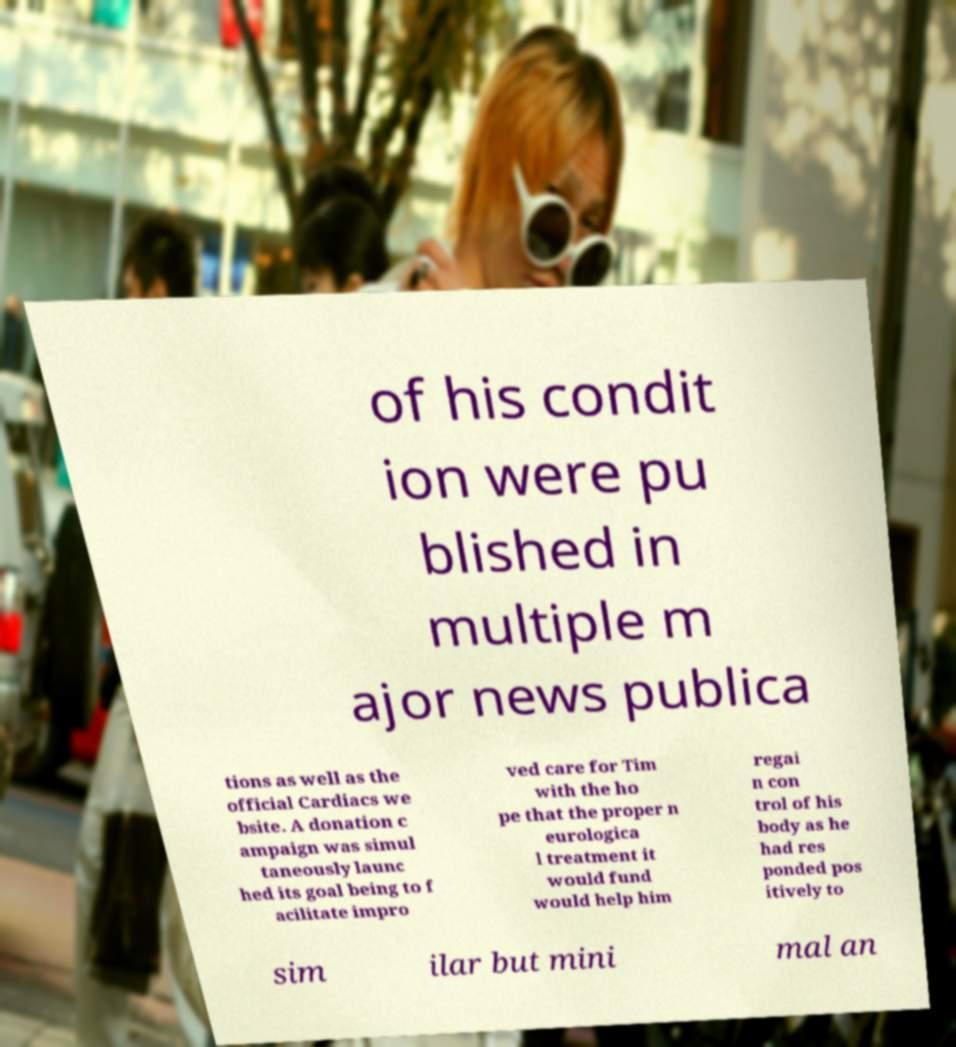Could you extract and type out the text from this image? of his condit ion were pu blished in multiple m ajor news publica tions as well as the official Cardiacs we bsite. A donation c ampaign was simul taneously launc hed its goal being to f acilitate impro ved care for Tim with the ho pe that the proper n eurologica l treatment it would fund would help him regai n con trol of his body as he had res ponded pos itively to sim ilar but mini mal an 